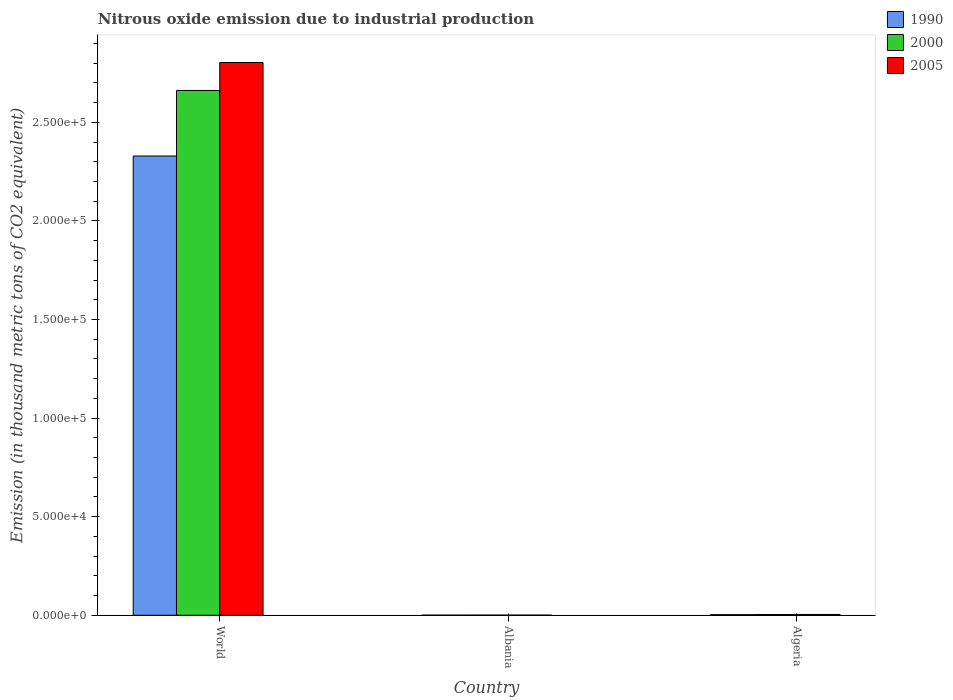How many different coloured bars are there?
Ensure brevity in your answer.  3. How many groups of bars are there?
Provide a succinct answer. 3. How many bars are there on the 2nd tick from the left?
Make the answer very short. 3. What is the label of the 1st group of bars from the left?
Provide a short and direct response. World. What is the amount of nitrous oxide emitted in 1990 in World?
Offer a terse response. 2.33e+05. Across all countries, what is the maximum amount of nitrous oxide emitted in 2000?
Offer a very short reply. 2.66e+05. Across all countries, what is the minimum amount of nitrous oxide emitted in 2005?
Ensure brevity in your answer.  74.5. In which country was the amount of nitrous oxide emitted in 1990 maximum?
Ensure brevity in your answer.  World. In which country was the amount of nitrous oxide emitted in 2005 minimum?
Provide a short and direct response. Albania. What is the total amount of nitrous oxide emitted in 2005 in the graph?
Offer a very short reply. 2.81e+05. What is the difference between the amount of nitrous oxide emitted in 2000 in Albania and that in World?
Make the answer very short. -2.66e+05. What is the difference between the amount of nitrous oxide emitted in 2000 in Algeria and the amount of nitrous oxide emitted in 1990 in Albania?
Make the answer very short. 335.3. What is the average amount of nitrous oxide emitted in 2000 per country?
Make the answer very short. 8.89e+04. What is the difference between the amount of nitrous oxide emitted of/in 1990 and amount of nitrous oxide emitted of/in 2000 in World?
Ensure brevity in your answer.  -3.32e+04. What is the ratio of the amount of nitrous oxide emitted in 1990 in Albania to that in World?
Make the answer very short. 0. What is the difference between the highest and the second highest amount of nitrous oxide emitted in 2000?
Ensure brevity in your answer.  -303.3. What is the difference between the highest and the lowest amount of nitrous oxide emitted in 2000?
Your answer should be compact. 2.66e+05. In how many countries, is the amount of nitrous oxide emitted in 2005 greater than the average amount of nitrous oxide emitted in 2005 taken over all countries?
Give a very brief answer. 1. Is the sum of the amount of nitrous oxide emitted in 2000 in Albania and Algeria greater than the maximum amount of nitrous oxide emitted in 2005 across all countries?
Keep it short and to the point. No. What does the 1st bar from the right in Albania represents?
Offer a terse response. 2005. Is it the case that in every country, the sum of the amount of nitrous oxide emitted in 2005 and amount of nitrous oxide emitted in 1990 is greater than the amount of nitrous oxide emitted in 2000?
Make the answer very short. Yes. How many bars are there?
Your response must be concise. 9. What is the difference between two consecutive major ticks on the Y-axis?
Give a very brief answer. 5.00e+04. Does the graph contain any zero values?
Ensure brevity in your answer.  No. Does the graph contain grids?
Ensure brevity in your answer.  No. What is the title of the graph?
Offer a terse response. Nitrous oxide emission due to industrial production. What is the label or title of the Y-axis?
Offer a very short reply. Emission (in thousand metric tons of CO2 equivalent). What is the Emission (in thousand metric tons of CO2 equivalent) in 1990 in World?
Ensure brevity in your answer.  2.33e+05. What is the Emission (in thousand metric tons of CO2 equivalent) of 2000 in World?
Your answer should be compact. 2.66e+05. What is the Emission (in thousand metric tons of CO2 equivalent) in 2005 in World?
Your answer should be compact. 2.80e+05. What is the Emission (in thousand metric tons of CO2 equivalent) in 1990 in Albania?
Keep it short and to the point. 38.9. What is the Emission (in thousand metric tons of CO2 equivalent) of 2000 in Albania?
Your response must be concise. 70.9. What is the Emission (in thousand metric tons of CO2 equivalent) in 2005 in Albania?
Your answer should be compact. 74.5. What is the Emission (in thousand metric tons of CO2 equivalent) in 1990 in Algeria?
Provide a succinct answer. 306.3. What is the Emission (in thousand metric tons of CO2 equivalent) in 2000 in Algeria?
Your answer should be compact. 374.2. What is the Emission (in thousand metric tons of CO2 equivalent) of 2005 in Algeria?
Ensure brevity in your answer.  403.3. Across all countries, what is the maximum Emission (in thousand metric tons of CO2 equivalent) of 1990?
Ensure brevity in your answer.  2.33e+05. Across all countries, what is the maximum Emission (in thousand metric tons of CO2 equivalent) of 2000?
Keep it short and to the point. 2.66e+05. Across all countries, what is the maximum Emission (in thousand metric tons of CO2 equivalent) in 2005?
Your answer should be compact. 2.80e+05. Across all countries, what is the minimum Emission (in thousand metric tons of CO2 equivalent) in 1990?
Offer a terse response. 38.9. Across all countries, what is the minimum Emission (in thousand metric tons of CO2 equivalent) in 2000?
Your response must be concise. 70.9. Across all countries, what is the minimum Emission (in thousand metric tons of CO2 equivalent) of 2005?
Offer a very short reply. 74.5. What is the total Emission (in thousand metric tons of CO2 equivalent) in 1990 in the graph?
Your response must be concise. 2.33e+05. What is the total Emission (in thousand metric tons of CO2 equivalent) in 2000 in the graph?
Your answer should be compact. 2.67e+05. What is the total Emission (in thousand metric tons of CO2 equivalent) of 2005 in the graph?
Ensure brevity in your answer.  2.81e+05. What is the difference between the Emission (in thousand metric tons of CO2 equivalent) of 1990 in World and that in Albania?
Ensure brevity in your answer.  2.33e+05. What is the difference between the Emission (in thousand metric tons of CO2 equivalent) in 2000 in World and that in Albania?
Provide a short and direct response. 2.66e+05. What is the difference between the Emission (in thousand metric tons of CO2 equivalent) in 2005 in World and that in Albania?
Offer a terse response. 2.80e+05. What is the difference between the Emission (in thousand metric tons of CO2 equivalent) of 1990 in World and that in Algeria?
Give a very brief answer. 2.33e+05. What is the difference between the Emission (in thousand metric tons of CO2 equivalent) of 2000 in World and that in Algeria?
Your answer should be very brief. 2.66e+05. What is the difference between the Emission (in thousand metric tons of CO2 equivalent) in 2005 in World and that in Algeria?
Make the answer very short. 2.80e+05. What is the difference between the Emission (in thousand metric tons of CO2 equivalent) in 1990 in Albania and that in Algeria?
Your answer should be compact. -267.4. What is the difference between the Emission (in thousand metric tons of CO2 equivalent) of 2000 in Albania and that in Algeria?
Make the answer very short. -303.3. What is the difference between the Emission (in thousand metric tons of CO2 equivalent) of 2005 in Albania and that in Algeria?
Your answer should be very brief. -328.8. What is the difference between the Emission (in thousand metric tons of CO2 equivalent) of 1990 in World and the Emission (in thousand metric tons of CO2 equivalent) of 2000 in Albania?
Make the answer very short. 2.33e+05. What is the difference between the Emission (in thousand metric tons of CO2 equivalent) of 1990 in World and the Emission (in thousand metric tons of CO2 equivalent) of 2005 in Albania?
Offer a very short reply. 2.33e+05. What is the difference between the Emission (in thousand metric tons of CO2 equivalent) of 2000 in World and the Emission (in thousand metric tons of CO2 equivalent) of 2005 in Albania?
Your answer should be compact. 2.66e+05. What is the difference between the Emission (in thousand metric tons of CO2 equivalent) of 1990 in World and the Emission (in thousand metric tons of CO2 equivalent) of 2000 in Algeria?
Your response must be concise. 2.33e+05. What is the difference between the Emission (in thousand metric tons of CO2 equivalent) in 1990 in World and the Emission (in thousand metric tons of CO2 equivalent) in 2005 in Algeria?
Ensure brevity in your answer.  2.33e+05. What is the difference between the Emission (in thousand metric tons of CO2 equivalent) in 2000 in World and the Emission (in thousand metric tons of CO2 equivalent) in 2005 in Algeria?
Keep it short and to the point. 2.66e+05. What is the difference between the Emission (in thousand metric tons of CO2 equivalent) in 1990 in Albania and the Emission (in thousand metric tons of CO2 equivalent) in 2000 in Algeria?
Your answer should be very brief. -335.3. What is the difference between the Emission (in thousand metric tons of CO2 equivalent) in 1990 in Albania and the Emission (in thousand metric tons of CO2 equivalent) in 2005 in Algeria?
Ensure brevity in your answer.  -364.4. What is the difference between the Emission (in thousand metric tons of CO2 equivalent) in 2000 in Albania and the Emission (in thousand metric tons of CO2 equivalent) in 2005 in Algeria?
Offer a very short reply. -332.4. What is the average Emission (in thousand metric tons of CO2 equivalent) in 1990 per country?
Provide a succinct answer. 7.78e+04. What is the average Emission (in thousand metric tons of CO2 equivalent) in 2000 per country?
Offer a very short reply. 8.89e+04. What is the average Emission (in thousand metric tons of CO2 equivalent) of 2005 per country?
Provide a short and direct response. 9.36e+04. What is the difference between the Emission (in thousand metric tons of CO2 equivalent) in 1990 and Emission (in thousand metric tons of CO2 equivalent) in 2000 in World?
Your answer should be compact. -3.32e+04. What is the difference between the Emission (in thousand metric tons of CO2 equivalent) in 1990 and Emission (in thousand metric tons of CO2 equivalent) in 2005 in World?
Your answer should be compact. -4.74e+04. What is the difference between the Emission (in thousand metric tons of CO2 equivalent) of 2000 and Emission (in thousand metric tons of CO2 equivalent) of 2005 in World?
Your response must be concise. -1.42e+04. What is the difference between the Emission (in thousand metric tons of CO2 equivalent) of 1990 and Emission (in thousand metric tons of CO2 equivalent) of 2000 in Albania?
Your response must be concise. -32. What is the difference between the Emission (in thousand metric tons of CO2 equivalent) in 1990 and Emission (in thousand metric tons of CO2 equivalent) in 2005 in Albania?
Your response must be concise. -35.6. What is the difference between the Emission (in thousand metric tons of CO2 equivalent) in 1990 and Emission (in thousand metric tons of CO2 equivalent) in 2000 in Algeria?
Your answer should be compact. -67.9. What is the difference between the Emission (in thousand metric tons of CO2 equivalent) in 1990 and Emission (in thousand metric tons of CO2 equivalent) in 2005 in Algeria?
Give a very brief answer. -97. What is the difference between the Emission (in thousand metric tons of CO2 equivalent) in 2000 and Emission (in thousand metric tons of CO2 equivalent) in 2005 in Algeria?
Your answer should be very brief. -29.1. What is the ratio of the Emission (in thousand metric tons of CO2 equivalent) in 1990 in World to that in Albania?
Keep it short and to the point. 5987.75. What is the ratio of the Emission (in thousand metric tons of CO2 equivalent) in 2000 in World to that in Albania?
Your answer should be compact. 3754.13. What is the ratio of the Emission (in thousand metric tons of CO2 equivalent) in 2005 in World to that in Albania?
Provide a short and direct response. 3762.93. What is the ratio of the Emission (in thousand metric tons of CO2 equivalent) of 1990 in World to that in Algeria?
Keep it short and to the point. 760.44. What is the ratio of the Emission (in thousand metric tons of CO2 equivalent) of 2000 in World to that in Algeria?
Your answer should be very brief. 711.3. What is the ratio of the Emission (in thousand metric tons of CO2 equivalent) of 2005 in World to that in Algeria?
Provide a short and direct response. 695.11. What is the ratio of the Emission (in thousand metric tons of CO2 equivalent) in 1990 in Albania to that in Algeria?
Make the answer very short. 0.13. What is the ratio of the Emission (in thousand metric tons of CO2 equivalent) of 2000 in Albania to that in Algeria?
Offer a terse response. 0.19. What is the ratio of the Emission (in thousand metric tons of CO2 equivalent) in 2005 in Albania to that in Algeria?
Your answer should be very brief. 0.18. What is the difference between the highest and the second highest Emission (in thousand metric tons of CO2 equivalent) in 1990?
Provide a short and direct response. 2.33e+05. What is the difference between the highest and the second highest Emission (in thousand metric tons of CO2 equivalent) of 2000?
Your answer should be very brief. 2.66e+05. What is the difference between the highest and the second highest Emission (in thousand metric tons of CO2 equivalent) of 2005?
Your response must be concise. 2.80e+05. What is the difference between the highest and the lowest Emission (in thousand metric tons of CO2 equivalent) of 1990?
Your response must be concise. 2.33e+05. What is the difference between the highest and the lowest Emission (in thousand metric tons of CO2 equivalent) in 2000?
Your response must be concise. 2.66e+05. What is the difference between the highest and the lowest Emission (in thousand metric tons of CO2 equivalent) of 2005?
Provide a succinct answer. 2.80e+05. 